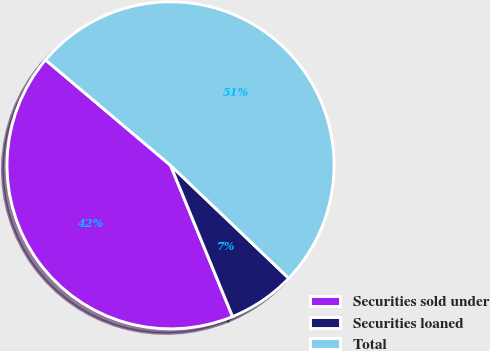<chart> <loc_0><loc_0><loc_500><loc_500><pie_chart><fcel>Securities sold under<fcel>Securities loaned<fcel>Total<nl><fcel>42.35%<fcel>6.67%<fcel>50.99%<nl></chart> 